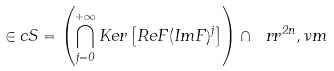<formula> <loc_0><loc_0><loc_500><loc_500>\in c S = \left ( \bigcap _ { j = 0 } ^ { + \infty } K e r \left [ R e F ( I m F ) ^ { j } \right ] \right ) \cap \ r r ^ { 2 n } , \nu m</formula> 